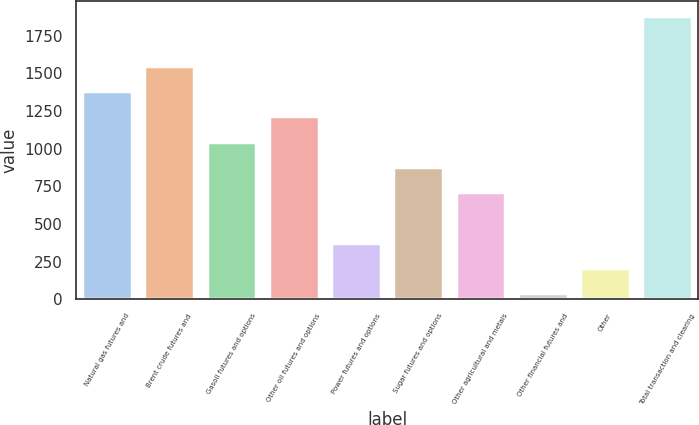<chart> <loc_0><loc_0><loc_500><loc_500><bar_chart><fcel>Natural gas futures and<fcel>Brent crude futures and<fcel>Gasoil futures and options<fcel>Other oil futures and options<fcel>Power futures and options<fcel>Sugar futures and options<fcel>Other agricultural and metals<fcel>Other financial futures and<fcel>Other<fcel>Total transaction and clearing<nl><fcel>1381.4<fcel>1548.7<fcel>1046.8<fcel>1214.1<fcel>377.6<fcel>879.5<fcel>712.2<fcel>43<fcel>210.3<fcel>1883.3<nl></chart> 